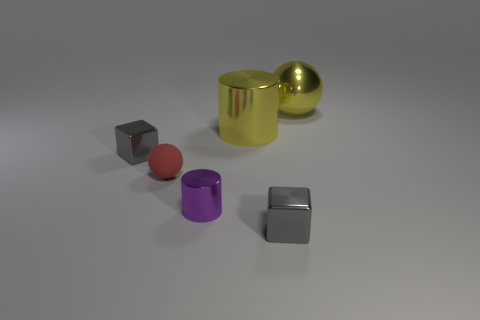There is a ball that is to the left of the metal ball; what is its size?
Provide a short and direct response. Small. The thing that is on the left side of the small cylinder and behind the red matte sphere has what shape?
Provide a short and direct response. Cube. How many tiny gray objects have the same material as the purple object?
Give a very brief answer. 2. Does the large shiny ball have the same color as the large shiny cylinder to the right of the purple metal cylinder?
Give a very brief answer. Yes. Are there more tiny gray shiny things than yellow metal spheres?
Provide a succinct answer. Yes. What is the color of the big metallic sphere?
Give a very brief answer. Yellow. Do the thing that is behind the big yellow shiny cylinder and the big metal cylinder have the same color?
Give a very brief answer. Yes. What number of big cylinders have the same color as the tiny cylinder?
Keep it short and to the point. 0. Does the big metal object on the left side of the large yellow ball have the same shape as the purple metallic thing?
Offer a very short reply. Yes. Are there fewer small metal things that are in front of the purple cylinder than metal things that are on the right side of the small red matte ball?
Provide a succinct answer. Yes. 